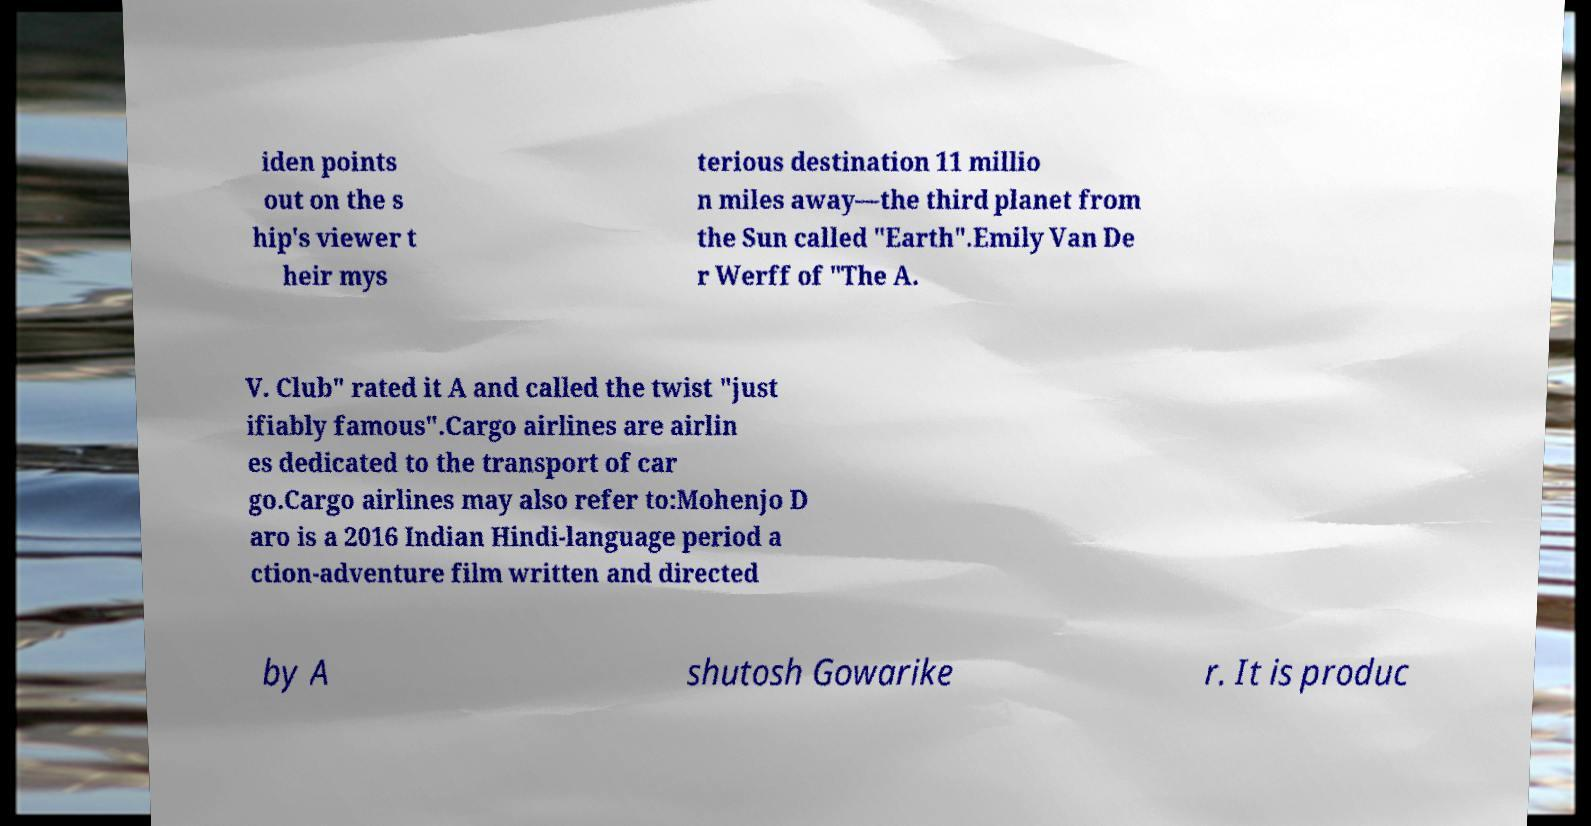I need the written content from this picture converted into text. Can you do that? iden points out on the s hip's viewer t heir mys terious destination 11 millio n miles away—the third planet from the Sun called "Earth".Emily Van De r Werff of "The A. V. Club" rated it A and called the twist "just ifiably famous".Cargo airlines are airlin es dedicated to the transport of car go.Cargo airlines may also refer to:Mohenjo D aro is a 2016 Indian Hindi-language period a ction-adventure film written and directed by A shutosh Gowarike r. It is produc 